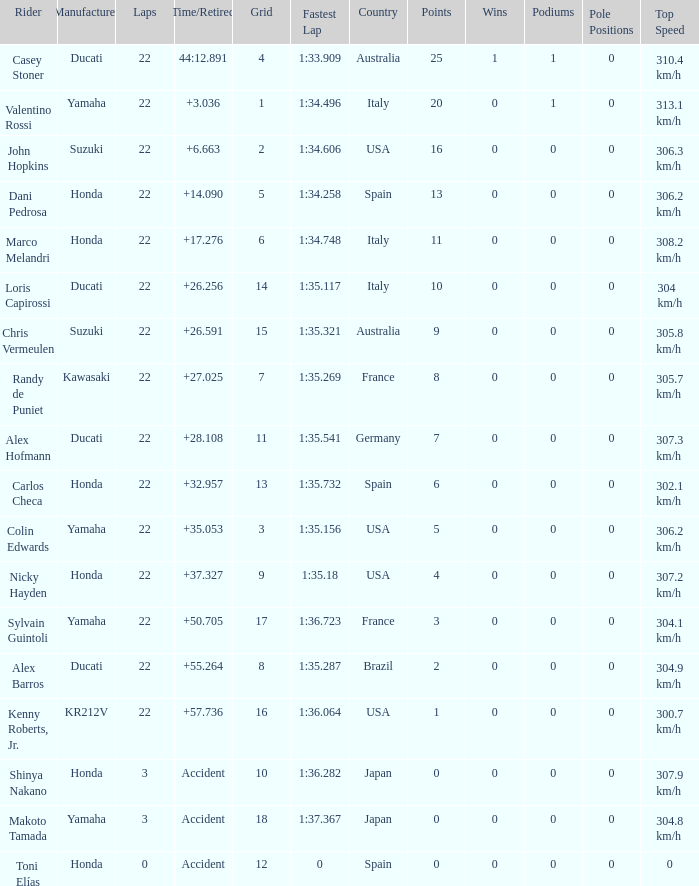What is the average grid for the competitiors who had laps smaller than 3? 12.0. 